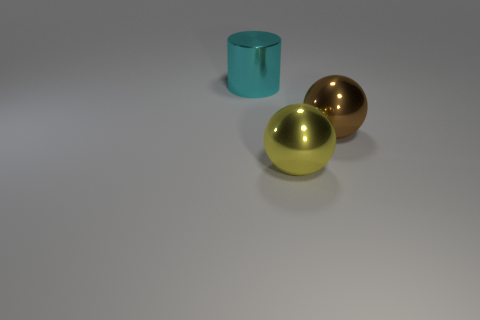How many objects are there, and what are their colors? There are three objects in the picture. Starting from the left, there's a cyan-colored cylinder, followed by a yellowish-green spherical object, and on the far right, there's a bronze or golden sphere. 